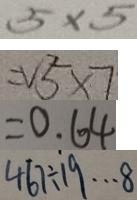Convert formula to latex. <formula><loc_0><loc_0><loc_500><loc_500>5 \times 5 
 = V ^ { 2 } _ { 5 } \times 7 
 = 0 . 6 4 
 4 6 7 \div 1 9 \cdots 8</formula> 